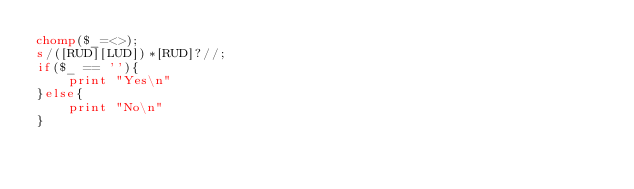<code> <loc_0><loc_0><loc_500><loc_500><_Perl_>chomp($_=<>);
s/([RUD][LUD])*[RUD]?//;
if($_ == ''){
	print "Yes\n"
}else{
	print "No\n"
}
</code> 